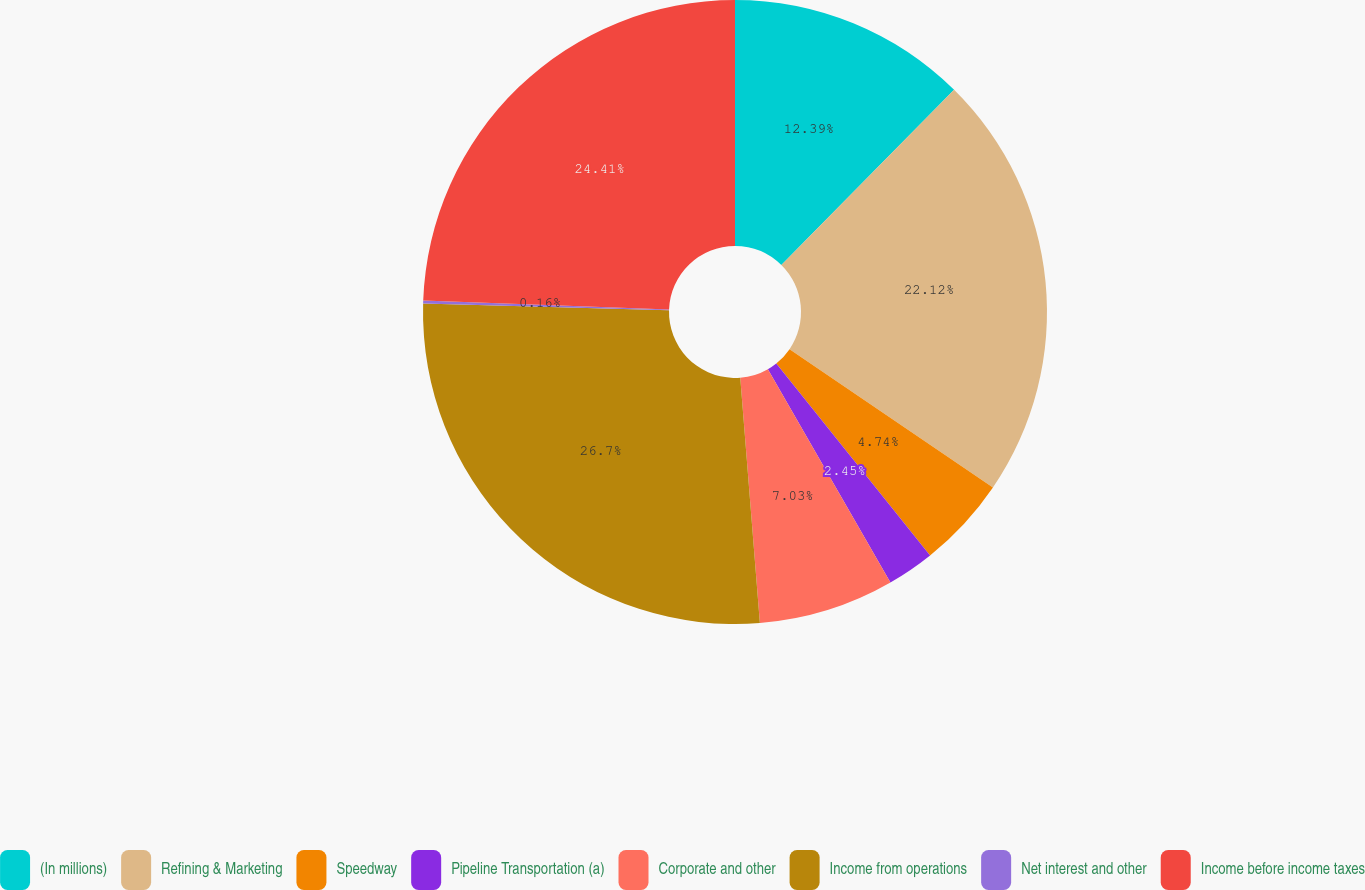Convert chart to OTSL. <chart><loc_0><loc_0><loc_500><loc_500><pie_chart><fcel>(In millions)<fcel>Refining & Marketing<fcel>Speedway<fcel>Pipeline Transportation (a)<fcel>Corporate and other<fcel>Income from operations<fcel>Net interest and other<fcel>Income before income taxes<nl><fcel>12.39%<fcel>22.12%<fcel>4.74%<fcel>2.45%<fcel>7.03%<fcel>26.7%<fcel>0.16%<fcel>24.41%<nl></chart> 